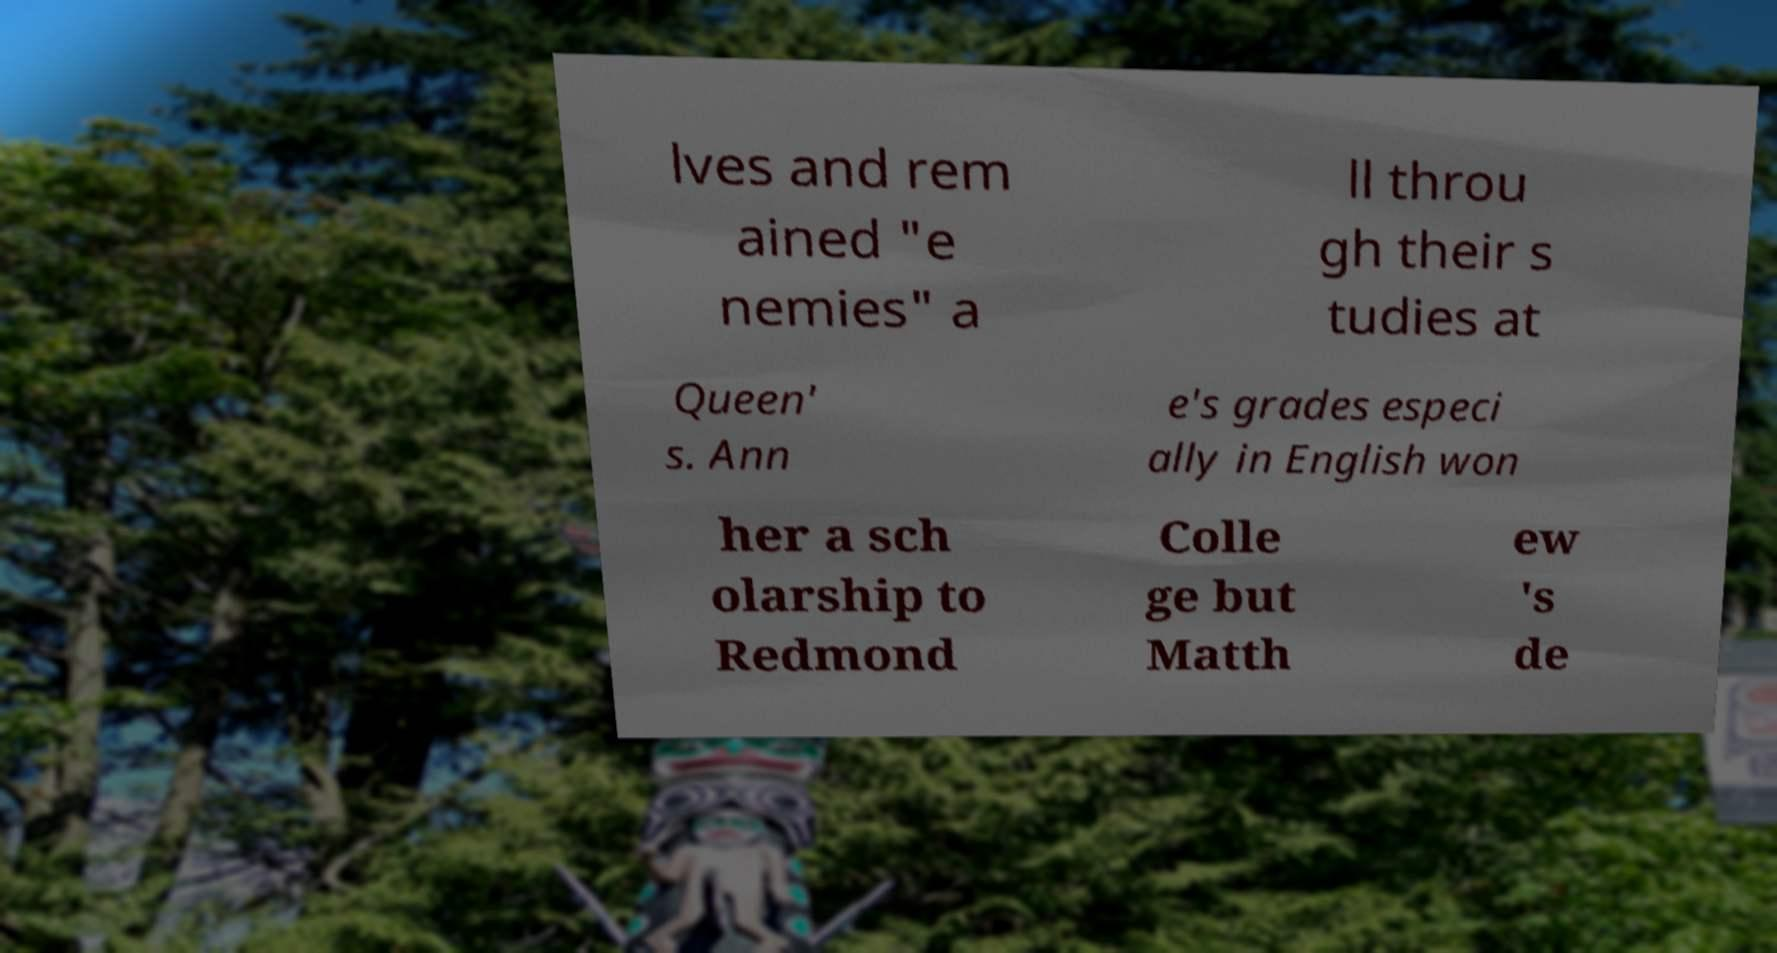I need the written content from this picture converted into text. Can you do that? lves and rem ained "e nemies" a ll throu gh their s tudies at Queen' s. Ann e's grades especi ally in English won her a sch olarship to Redmond Colle ge but Matth ew 's de 